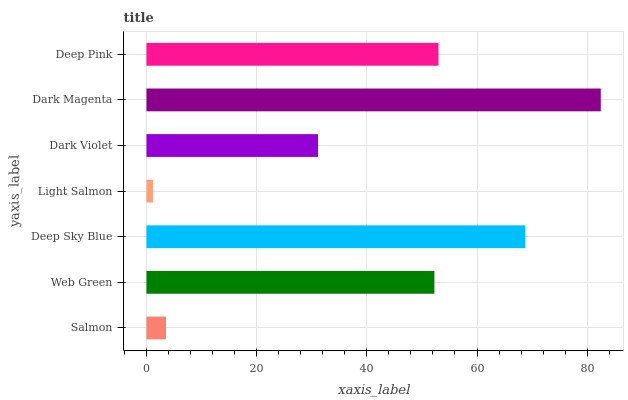Is Light Salmon the minimum?
Answer yes or no. Yes. Is Dark Magenta the maximum?
Answer yes or no. Yes. Is Web Green the minimum?
Answer yes or no. No. Is Web Green the maximum?
Answer yes or no. No. Is Web Green greater than Salmon?
Answer yes or no. Yes. Is Salmon less than Web Green?
Answer yes or no. Yes. Is Salmon greater than Web Green?
Answer yes or no. No. Is Web Green less than Salmon?
Answer yes or no. No. Is Web Green the high median?
Answer yes or no. Yes. Is Web Green the low median?
Answer yes or no. Yes. Is Deep Pink the high median?
Answer yes or no. No. Is Light Salmon the low median?
Answer yes or no. No. 